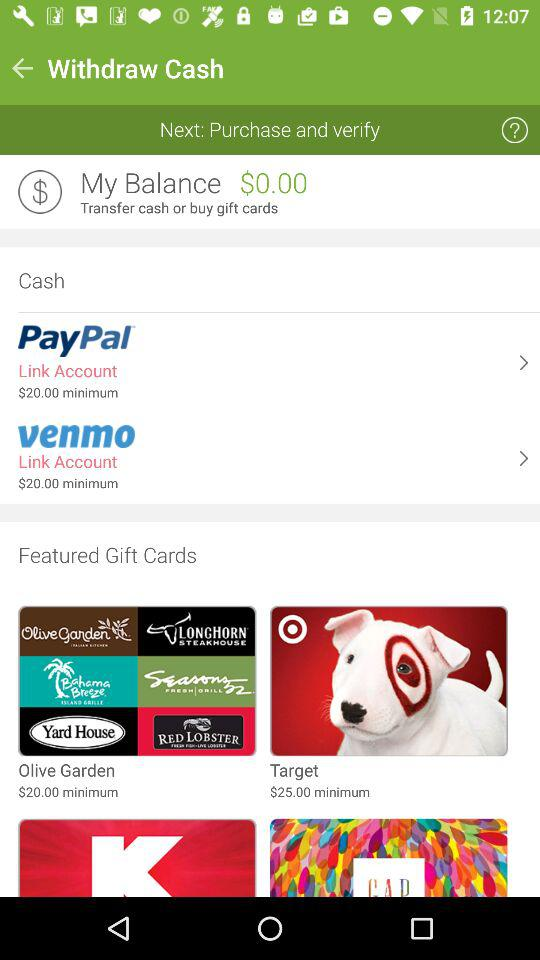What is the minimum cost of the Olive Garden featured gift card? The minimum cost of the Olive Garden featured gift card is $20. 